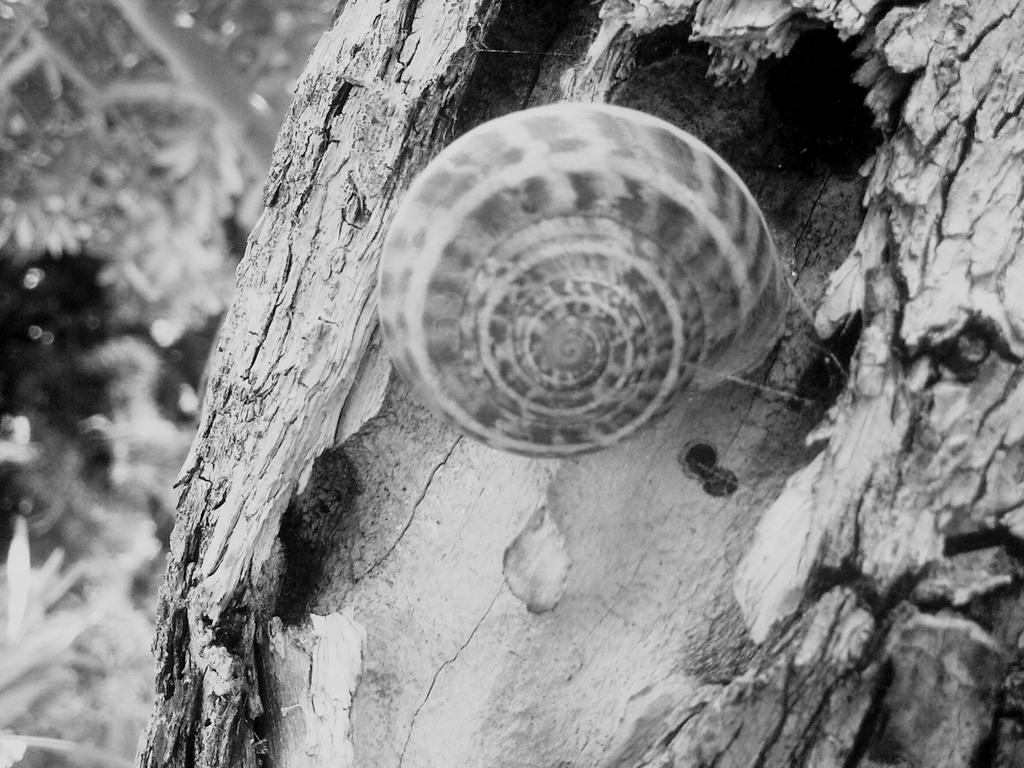What is the color scheme of the image? The image is black and white. What is the main subject in the center of the image? There is a tree in the center of the image. Can you describe any additional details about the tree? There is a snail on the tree. What can be seen in the background of the image? There are trees visible in the background of the image. What type of metal is used to construct the stem of the tree in the image? There is no metal used to construct the tree in the image, as it is a natural object. 